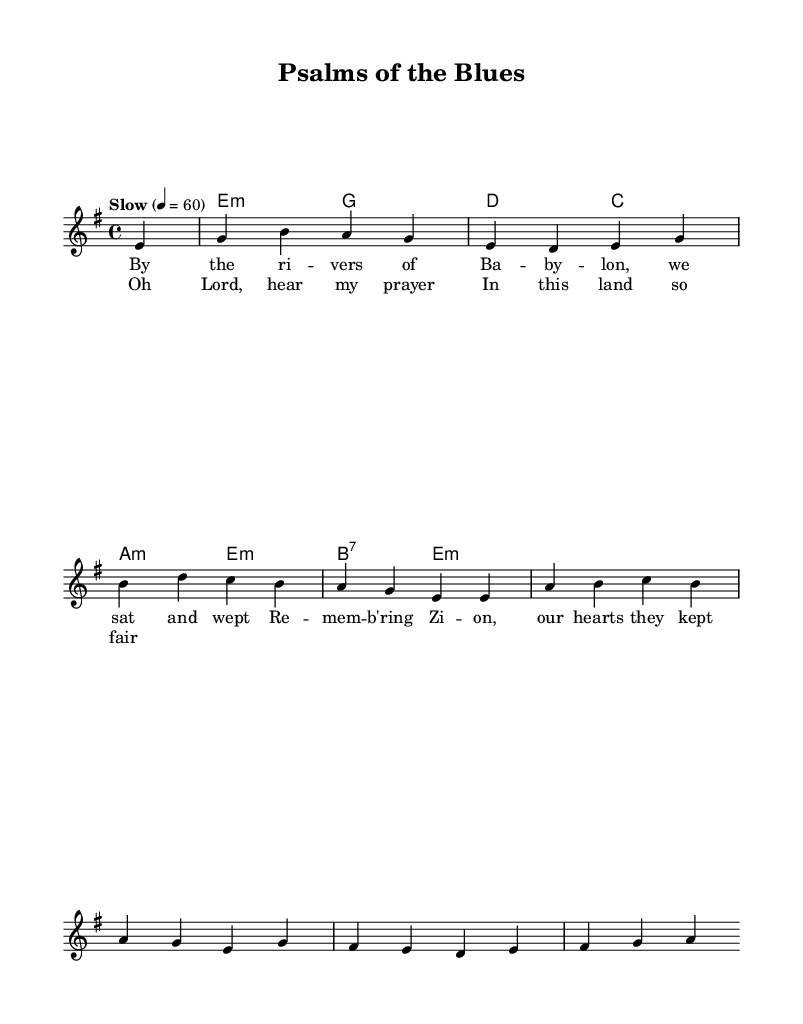What is the key signature of this music? The key signature is E minor, indicated by one sharp (F#) shown at the beginning of the score.
Answer: E minor What is the time signature of the piece? The time signature is 4/4, which means there are four beats per measure, as noted at the beginning of the score after the key signature.
Answer: 4/4 What is the tempo marking for this piece? The tempo marking is "Slow," which is noted above the staff. The numerical indication shows a speed of 60 beats per minute when marked by the quarter note.
Answer: Slow How many measures does the melody section contain? By counting the measures in the melody, there are 6 measures before the chorus starts. Each line generally corresponds to a measure and the sections are clearly delineated in the notation.
Answer: 6 What type of musical form is used in this piece? The piece follows a blues structure, typically featuring a call-and-response format, as indicated by the verse and chorus sections. This structure aligns with traditional blues ballads.
Answer: Blues form What is the first lyric of the verse? The first lyric of the verse is "By the rivers of Babylon," which starts the lyrical content for this piece and is evident directly under the melody notes.
Answer: By the rivers of Babylon What chord follows E minor in the harmony? The next chord after E minor is G major as represented in the chord progression. It follows logically as the second chord after E minor from the harmonic accompaniment.
Answer: G major 